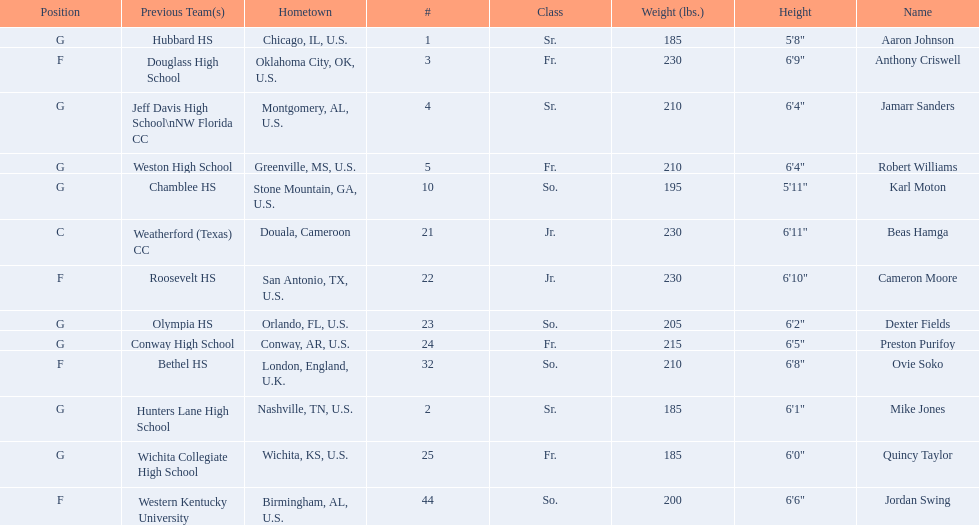What is the number of seniors on the team? 3. 